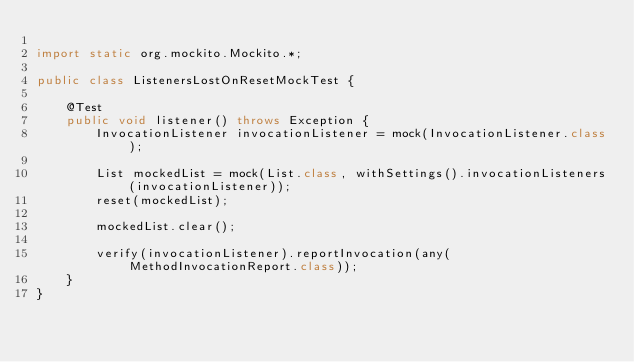Convert code to text. <code><loc_0><loc_0><loc_500><loc_500><_Java_>
import static org.mockito.Mockito.*;

public class ListenersLostOnResetMockTest {

    @Test
    public void listener() throws Exception {
        InvocationListener invocationListener = mock(InvocationListener.class);

        List mockedList = mock(List.class, withSettings().invocationListeners(invocationListener));
        reset(mockedList);

        mockedList.clear();

        verify(invocationListener).reportInvocation(any(MethodInvocationReport.class));
    }
}
</code> 